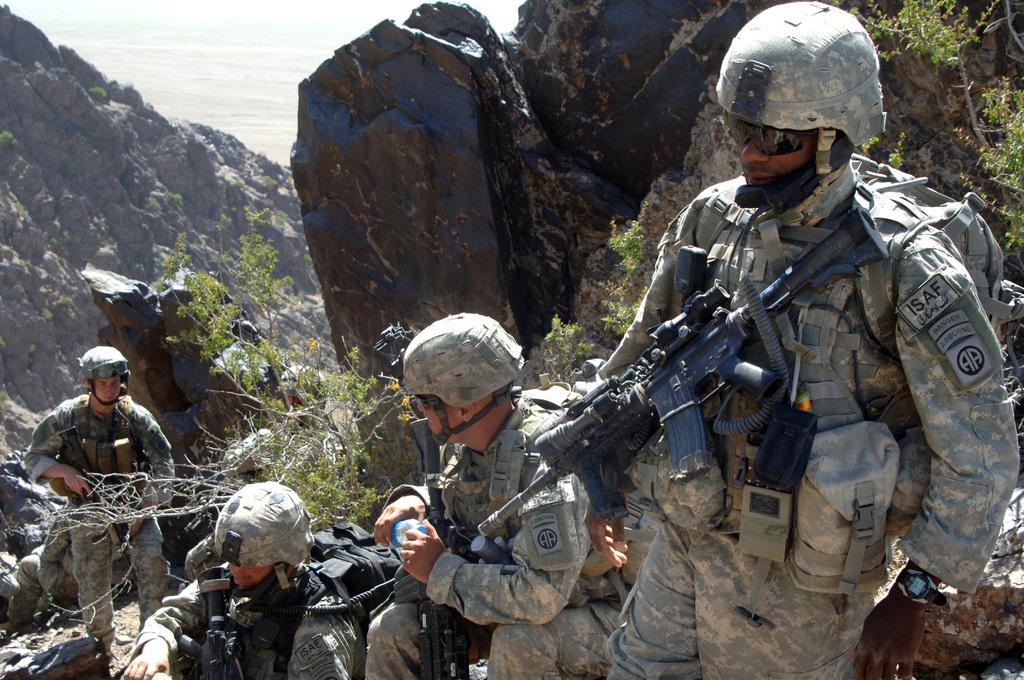Describe this image in one or two sentences. In this image there are a few soldiers in between the rocks and holding weapons, water and few plants 